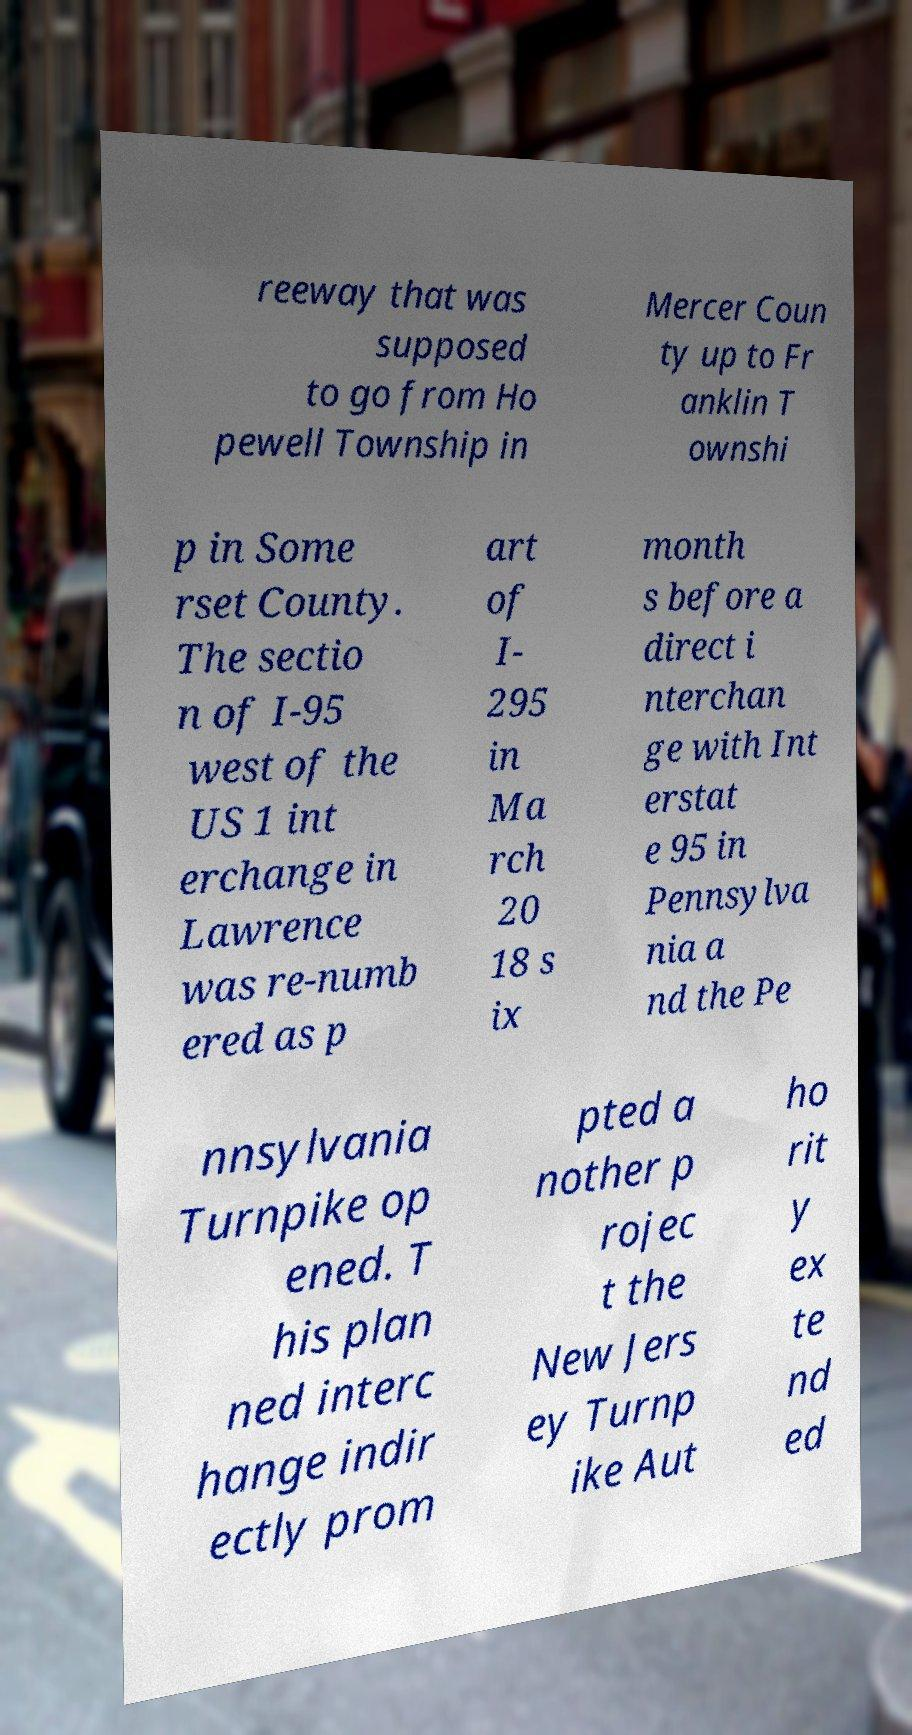Can you read and provide the text displayed in the image?This photo seems to have some interesting text. Can you extract and type it out for me? reeway that was supposed to go from Ho pewell Township in Mercer Coun ty up to Fr anklin T ownshi p in Some rset County. The sectio n of I-95 west of the US 1 int erchange in Lawrence was re-numb ered as p art of I- 295 in Ma rch 20 18 s ix month s before a direct i nterchan ge with Int erstat e 95 in Pennsylva nia a nd the Pe nnsylvania Turnpike op ened. T his plan ned interc hange indir ectly prom pted a nother p rojec t the New Jers ey Turnp ike Aut ho rit y ex te nd ed 